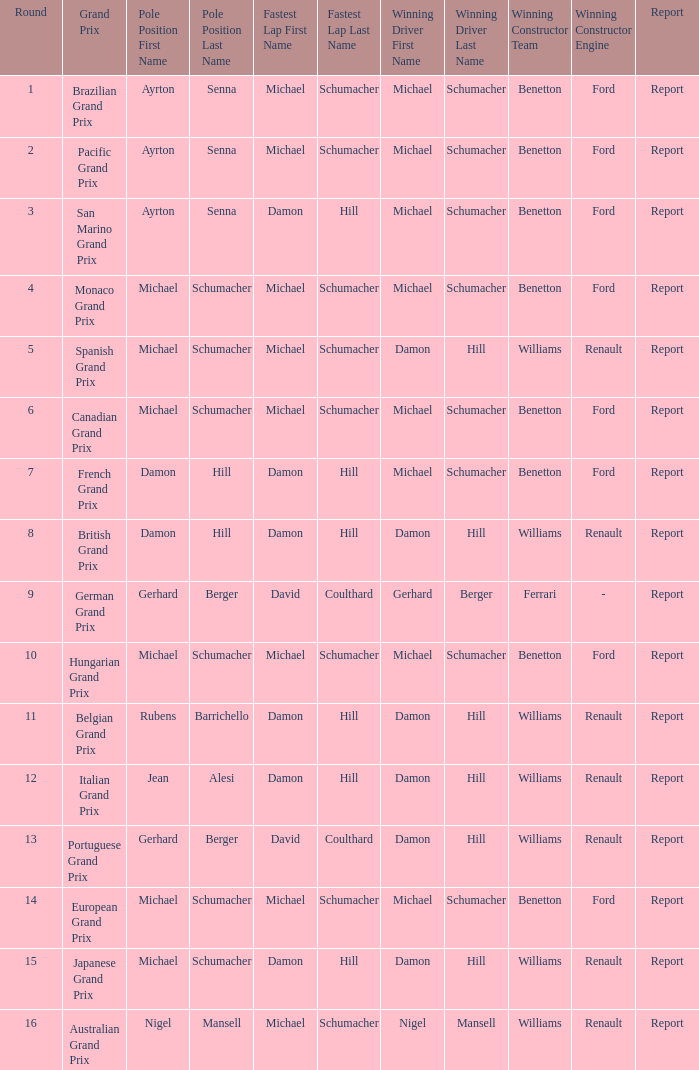Name the pole position at the japanese grand prix when the fastest lap is damon hill Michael Schumacher. 